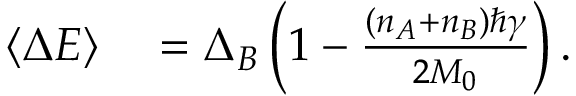<formula> <loc_0><loc_0><loc_500><loc_500>\begin{array} { r l } { \left \langle { \Delta E } \right \rangle } & = \Delta _ { B } \left ( 1 - \frac { \left ( n _ { A } + n _ { B } \right ) \hbar { \gamma } } { 2 M _ { 0 } } \right ) . } \end{array}</formula> 